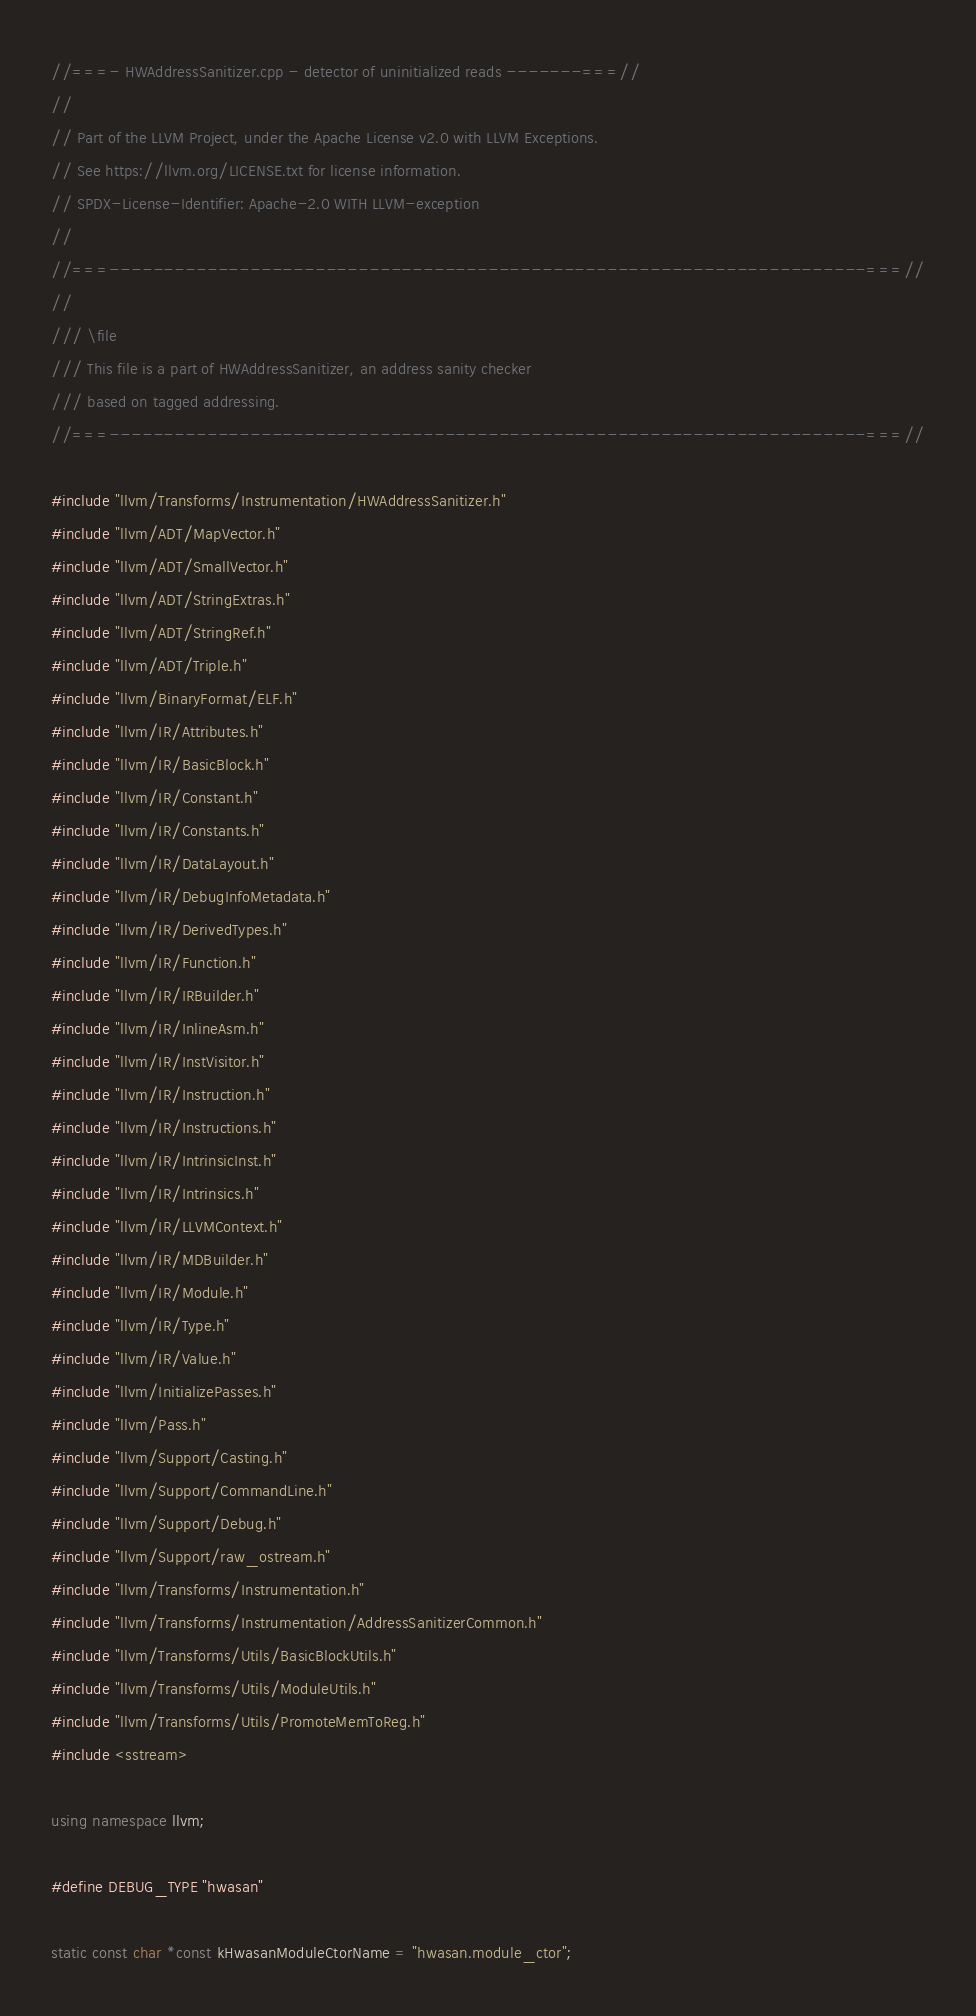<code> <loc_0><loc_0><loc_500><loc_500><_C++_>//===- HWAddressSanitizer.cpp - detector of uninitialized reads -------===//
//
// Part of the LLVM Project, under the Apache License v2.0 with LLVM Exceptions.
// See https://llvm.org/LICENSE.txt for license information.
// SPDX-License-Identifier: Apache-2.0 WITH LLVM-exception
//
//===----------------------------------------------------------------------===//
//
/// \file
/// This file is a part of HWAddressSanitizer, an address sanity checker
/// based on tagged addressing.
//===----------------------------------------------------------------------===//

#include "llvm/Transforms/Instrumentation/HWAddressSanitizer.h"
#include "llvm/ADT/MapVector.h"
#include "llvm/ADT/SmallVector.h"
#include "llvm/ADT/StringExtras.h"
#include "llvm/ADT/StringRef.h"
#include "llvm/ADT/Triple.h"
#include "llvm/BinaryFormat/ELF.h"
#include "llvm/IR/Attributes.h"
#include "llvm/IR/BasicBlock.h"
#include "llvm/IR/Constant.h"
#include "llvm/IR/Constants.h"
#include "llvm/IR/DataLayout.h"
#include "llvm/IR/DebugInfoMetadata.h"
#include "llvm/IR/DerivedTypes.h"
#include "llvm/IR/Function.h"
#include "llvm/IR/IRBuilder.h"
#include "llvm/IR/InlineAsm.h"
#include "llvm/IR/InstVisitor.h"
#include "llvm/IR/Instruction.h"
#include "llvm/IR/Instructions.h"
#include "llvm/IR/IntrinsicInst.h"
#include "llvm/IR/Intrinsics.h"
#include "llvm/IR/LLVMContext.h"
#include "llvm/IR/MDBuilder.h"
#include "llvm/IR/Module.h"
#include "llvm/IR/Type.h"
#include "llvm/IR/Value.h"
#include "llvm/InitializePasses.h"
#include "llvm/Pass.h"
#include "llvm/Support/Casting.h"
#include "llvm/Support/CommandLine.h"
#include "llvm/Support/Debug.h"
#include "llvm/Support/raw_ostream.h"
#include "llvm/Transforms/Instrumentation.h"
#include "llvm/Transforms/Instrumentation/AddressSanitizerCommon.h"
#include "llvm/Transforms/Utils/BasicBlockUtils.h"
#include "llvm/Transforms/Utils/ModuleUtils.h"
#include "llvm/Transforms/Utils/PromoteMemToReg.h"
#include <sstream>

using namespace llvm;

#define DEBUG_TYPE "hwasan"

static const char *const kHwasanModuleCtorName = "hwasan.module_ctor";</code> 